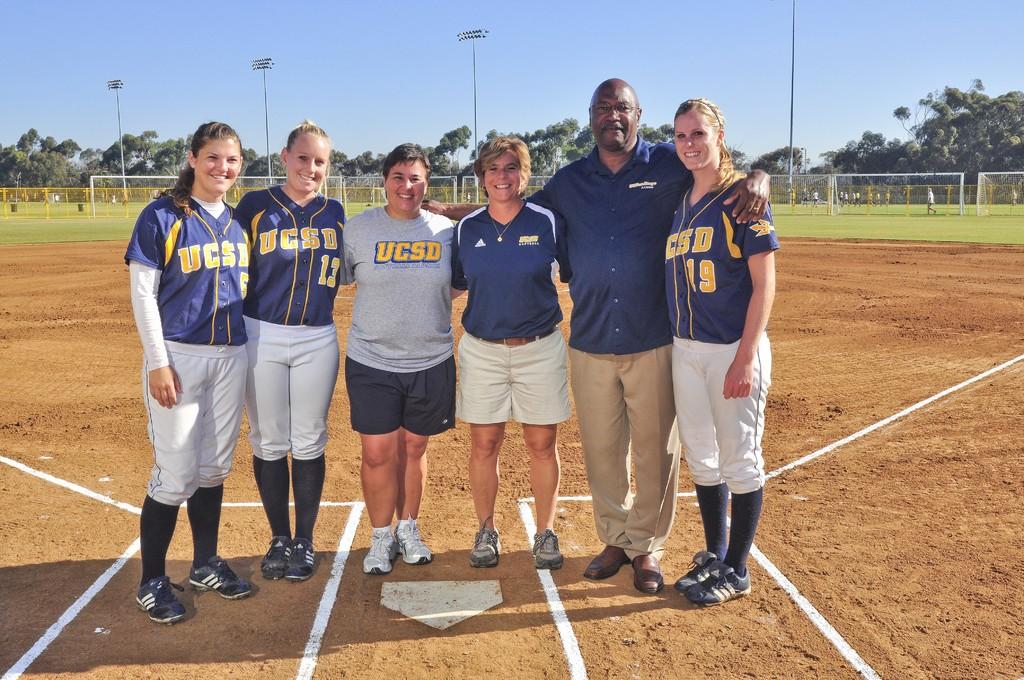What team do they play for?
Your response must be concise. Ucsd. Is this a college in south dakota?
Provide a short and direct response. Yes. 